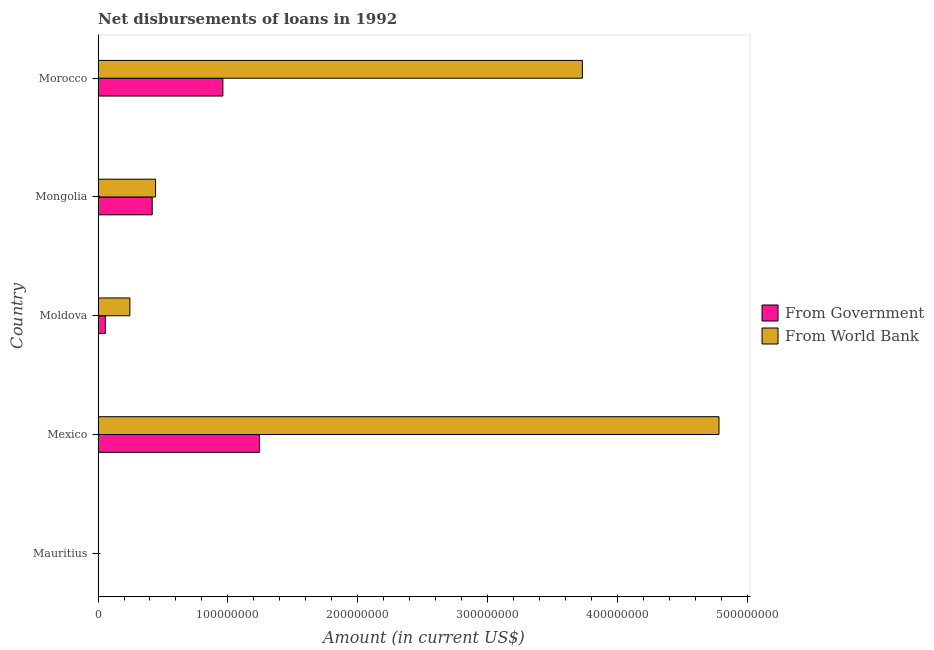How many different coloured bars are there?
Your answer should be very brief. 2. Are the number of bars on each tick of the Y-axis equal?
Offer a terse response. No. How many bars are there on the 2nd tick from the top?
Ensure brevity in your answer.  2. What is the net disbursements of loan from government in Morocco?
Your response must be concise. 9.61e+07. Across all countries, what is the maximum net disbursements of loan from world bank?
Your answer should be very brief. 4.78e+08. In which country was the net disbursements of loan from government maximum?
Your answer should be very brief. Mexico. What is the total net disbursements of loan from world bank in the graph?
Your answer should be compact. 9.20e+08. What is the difference between the net disbursements of loan from world bank in Mexico and that in Mongolia?
Provide a short and direct response. 4.34e+08. What is the difference between the net disbursements of loan from world bank in Mexico and the net disbursements of loan from government in Mauritius?
Your response must be concise. 4.78e+08. What is the average net disbursements of loan from world bank per country?
Provide a succinct answer. 1.84e+08. What is the difference between the net disbursements of loan from world bank and net disbursements of loan from government in Mexico?
Offer a terse response. 3.54e+08. In how many countries, is the net disbursements of loan from world bank greater than 40000000 US$?
Your answer should be very brief. 3. What is the ratio of the net disbursements of loan from world bank in Mexico to that in Mongolia?
Keep it short and to the point. 10.79. What is the difference between the highest and the second highest net disbursements of loan from government?
Your answer should be compact. 2.81e+07. What is the difference between the highest and the lowest net disbursements of loan from world bank?
Provide a short and direct response. 4.78e+08. What is the difference between two consecutive major ticks on the X-axis?
Make the answer very short. 1.00e+08. Where does the legend appear in the graph?
Ensure brevity in your answer.  Center right. How are the legend labels stacked?
Your answer should be compact. Vertical. What is the title of the graph?
Your response must be concise. Net disbursements of loans in 1992. Does "Age 65(female)" appear as one of the legend labels in the graph?
Your answer should be compact. No. What is the Amount (in current US$) in From Government in Mauritius?
Your response must be concise. 0. What is the Amount (in current US$) of From World Bank in Mauritius?
Your answer should be compact. 0. What is the Amount (in current US$) of From Government in Mexico?
Offer a very short reply. 1.24e+08. What is the Amount (in current US$) of From World Bank in Mexico?
Keep it short and to the point. 4.78e+08. What is the Amount (in current US$) of From Government in Moldova?
Make the answer very short. 5.62e+06. What is the Amount (in current US$) in From World Bank in Moldova?
Offer a terse response. 2.45e+07. What is the Amount (in current US$) of From Government in Mongolia?
Provide a short and direct response. 4.17e+07. What is the Amount (in current US$) of From World Bank in Mongolia?
Keep it short and to the point. 4.43e+07. What is the Amount (in current US$) in From Government in Morocco?
Keep it short and to the point. 9.61e+07. What is the Amount (in current US$) of From World Bank in Morocco?
Offer a terse response. 3.73e+08. Across all countries, what is the maximum Amount (in current US$) in From Government?
Offer a very short reply. 1.24e+08. Across all countries, what is the maximum Amount (in current US$) in From World Bank?
Ensure brevity in your answer.  4.78e+08. Across all countries, what is the minimum Amount (in current US$) in From Government?
Ensure brevity in your answer.  0. Across all countries, what is the minimum Amount (in current US$) of From World Bank?
Provide a short and direct response. 0. What is the total Amount (in current US$) of From Government in the graph?
Ensure brevity in your answer.  2.68e+08. What is the total Amount (in current US$) in From World Bank in the graph?
Make the answer very short. 9.20e+08. What is the difference between the Amount (in current US$) of From Government in Mexico and that in Moldova?
Give a very brief answer. 1.19e+08. What is the difference between the Amount (in current US$) in From World Bank in Mexico and that in Moldova?
Keep it short and to the point. 4.54e+08. What is the difference between the Amount (in current US$) of From Government in Mexico and that in Mongolia?
Keep it short and to the point. 8.26e+07. What is the difference between the Amount (in current US$) of From World Bank in Mexico and that in Mongolia?
Keep it short and to the point. 4.34e+08. What is the difference between the Amount (in current US$) of From Government in Mexico and that in Morocco?
Your answer should be compact. 2.81e+07. What is the difference between the Amount (in current US$) in From World Bank in Mexico and that in Morocco?
Keep it short and to the point. 1.05e+08. What is the difference between the Amount (in current US$) of From Government in Moldova and that in Mongolia?
Keep it short and to the point. -3.61e+07. What is the difference between the Amount (in current US$) in From World Bank in Moldova and that in Mongolia?
Your answer should be very brief. -1.98e+07. What is the difference between the Amount (in current US$) in From Government in Moldova and that in Morocco?
Keep it short and to the point. -9.05e+07. What is the difference between the Amount (in current US$) in From World Bank in Moldova and that in Morocco?
Make the answer very short. -3.49e+08. What is the difference between the Amount (in current US$) of From Government in Mongolia and that in Morocco?
Offer a very short reply. -5.44e+07. What is the difference between the Amount (in current US$) in From World Bank in Mongolia and that in Morocco?
Make the answer very short. -3.29e+08. What is the difference between the Amount (in current US$) in From Government in Mexico and the Amount (in current US$) in From World Bank in Moldova?
Provide a succinct answer. 9.98e+07. What is the difference between the Amount (in current US$) in From Government in Mexico and the Amount (in current US$) in From World Bank in Mongolia?
Your answer should be compact. 8.00e+07. What is the difference between the Amount (in current US$) in From Government in Mexico and the Amount (in current US$) in From World Bank in Morocco?
Provide a short and direct response. -2.49e+08. What is the difference between the Amount (in current US$) of From Government in Moldova and the Amount (in current US$) of From World Bank in Mongolia?
Provide a short and direct response. -3.87e+07. What is the difference between the Amount (in current US$) of From Government in Moldova and the Amount (in current US$) of From World Bank in Morocco?
Offer a very short reply. -3.67e+08. What is the difference between the Amount (in current US$) of From Government in Mongolia and the Amount (in current US$) of From World Bank in Morocco?
Make the answer very short. -3.31e+08. What is the average Amount (in current US$) of From Government per country?
Offer a terse response. 5.36e+07. What is the average Amount (in current US$) in From World Bank per country?
Offer a terse response. 1.84e+08. What is the difference between the Amount (in current US$) in From Government and Amount (in current US$) in From World Bank in Mexico?
Keep it short and to the point. -3.54e+08. What is the difference between the Amount (in current US$) of From Government and Amount (in current US$) of From World Bank in Moldova?
Your answer should be very brief. -1.89e+07. What is the difference between the Amount (in current US$) in From Government and Amount (in current US$) in From World Bank in Mongolia?
Provide a short and direct response. -2.60e+06. What is the difference between the Amount (in current US$) of From Government and Amount (in current US$) of From World Bank in Morocco?
Your response must be concise. -2.77e+08. What is the ratio of the Amount (in current US$) in From Government in Mexico to that in Moldova?
Ensure brevity in your answer.  22.12. What is the ratio of the Amount (in current US$) in From World Bank in Mexico to that in Moldova?
Your answer should be very brief. 19.51. What is the ratio of the Amount (in current US$) of From Government in Mexico to that in Mongolia?
Your answer should be very brief. 2.98. What is the ratio of the Amount (in current US$) in From World Bank in Mexico to that in Mongolia?
Provide a short and direct response. 10.79. What is the ratio of the Amount (in current US$) of From Government in Mexico to that in Morocco?
Ensure brevity in your answer.  1.29. What is the ratio of the Amount (in current US$) of From World Bank in Mexico to that in Morocco?
Make the answer very short. 1.28. What is the ratio of the Amount (in current US$) of From Government in Moldova to that in Mongolia?
Provide a short and direct response. 0.13. What is the ratio of the Amount (in current US$) in From World Bank in Moldova to that in Mongolia?
Ensure brevity in your answer.  0.55. What is the ratio of the Amount (in current US$) of From Government in Moldova to that in Morocco?
Your answer should be very brief. 0.06. What is the ratio of the Amount (in current US$) of From World Bank in Moldova to that in Morocco?
Provide a short and direct response. 0.07. What is the ratio of the Amount (in current US$) in From Government in Mongolia to that in Morocco?
Make the answer very short. 0.43. What is the ratio of the Amount (in current US$) in From World Bank in Mongolia to that in Morocco?
Offer a very short reply. 0.12. What is the difference between the highest and the second highest Amount (in current US$) of From Government?
Ensure brevity in your answer.  2.81e+07. What is the difference between the highest and the second highest Amount (in current US$) in From World Bank?
Keep it short and to the point. 1.05e+08. What is the difference between the highest and the lowest Amount (in current US$) of From Government?
Give a very brief answer. 1.24e+08. What is the difference between the highest and the lowest Amount (in current US$) in From World Bank?
Provide a short and direct response. 4.78e+08. 